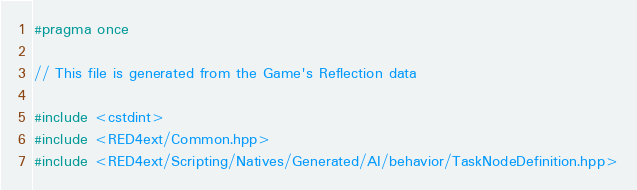Convert code to text. <code><loc_0><loc_0><loc_500><loc_500><_C++_>#pragma once

// This file is generated from the Game's Reflection data

#include <cstdint>
#include <RED4ext/Common.hpp>
#include <RED4ext/Scripting/Natives/Generated/AI/behavior/TaskNodeDefinition.hpp>
</code> 